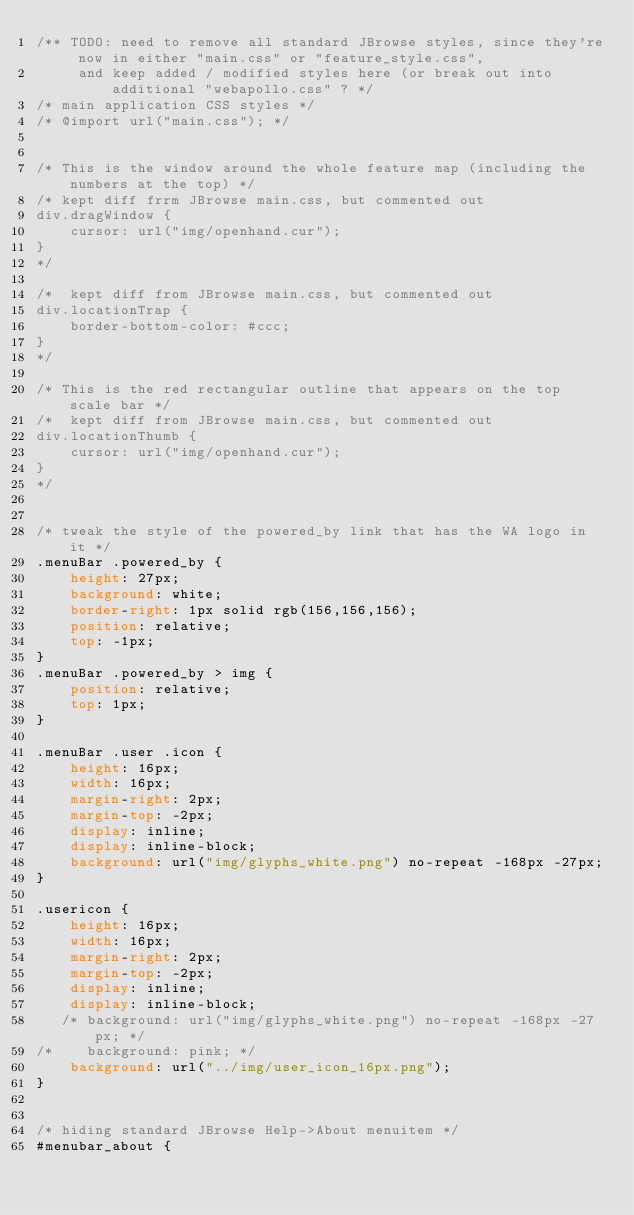Convert code to text. <code><loc_0><loc_0><loc_500><loc_500><_CSS_>/** TODO: need to remove all standard JBrowse styles, since they're now in either "main.css" or "feature_style.css", 
     and keep added / modified styles here (or break out into additional "webapollo.css" ? */
/* main application CSS styles */
/* @import url("main.css"); */


/* This is the window around the whole feature map (including the numbers at the top) */
/* kept diff frrm JBrowse main.css, but commented out
div.dragWindow {
    cursor: url("img/openhand.cur");
}
*/

/*  kept diff from JBrowse main.css, but commented out
div.locationTrap {
    border-bottom-color: #ccc;
}
*/

/* This is the red rectangular outline that appears on the top scale bar */
/*  kept diff from JBrowse main.css, but commented out
div.locationThumb {
    cursor: url("img/openhand.cur");
}
*/


/* tweak the style of the powered_by link that has the WA logo in it */
.menuBar .powered_by {
    height: 27px;
    background: white;
    border-right: 1px solid rgb(156,156,156);
    position: relative;
    top: -1px;
}
.menuBar .powered_by > img {
    position: relative;
    top: 1px;
}

.menuBar .user .icon {
    height: 16px;
    width: 16px;
    margin-right: 2px;
    margin-top: -2px;
    display: inline;
    display: inline-block;
    background: url("img/glyphs_white.png") no-repeat -168px -27px;
}

.usericon {
    height: 16px;
    width: 16px;
    margin-right: 2px;
    margin-top: -2px;
    display: inline;
    display: inline-block;
   /* background: url("img/glyphs_white.png") no-repeat -168px -27px; */
/*    background: pink; */
    background: url("../img/user_icon_16px.png");
}


/* hiding standard JBrowse Help->About menuitem */
#menubar_about {</code> 